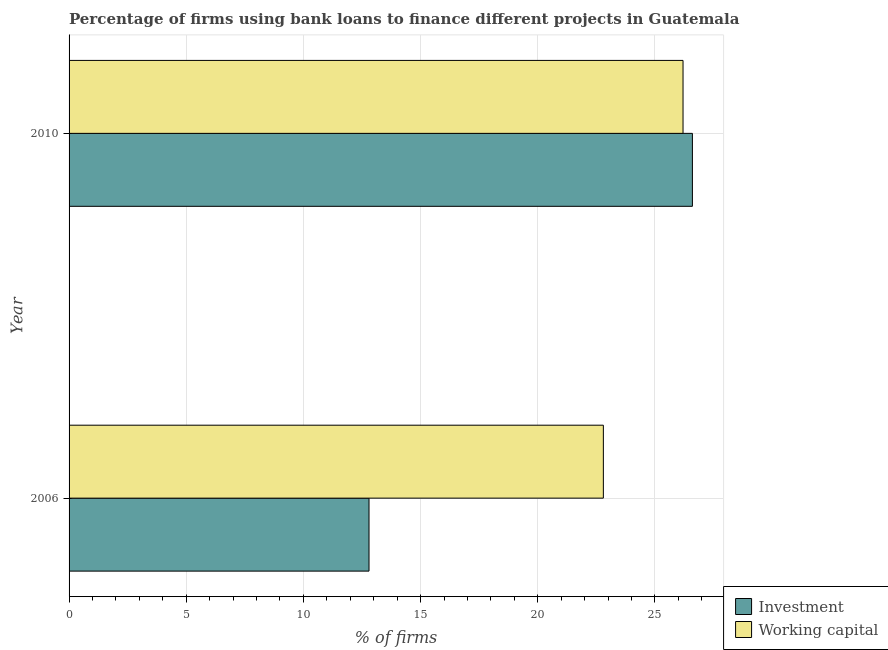Are the number of bars per tick equal to the number of legend labels?
Your answer should be compact. Yes. How many bars are there on the 2nd tick from the bottom?
Offer a very short reply. 2. What is the label of the 1st group of bars from the top?
Provide a short and direct response. 2010. In how many cases, is the number of bars for a given year not equal to the number of legend labels?
Offer a terse response. 0. What is the percentage of firms using banks to finance investment in 2006?
Give a very brief answer. 12.8. Across all years, what is the maximum percentage of firms using banks to finance working capital?
Your answer should be compact. 26.2. What is the difference between the percentage of firms using banks to finance investment in 2010 and the percentage of firms using banks to finance working capital in 2006?
Your answer should be compact. 3.8. In how many years, is the percentage of firms using banks to finance investment greater than 19 %?
Your answer should be very brief. 1. What is the ratio of the percentage of firms using banks to finance working capital in 2006 to that in 2010?
Make the answer very short. 0.87. Is the percentage of firms using banks to finance investment in 2006 less than that in 2010?
Provide a short and direct response. Yes. Is the difference between the percentage of firms using banks to finance investment in 2006 and 2010 greater than the difference between the percentage of firms using banks to finance working capital in 2006 and 2010?
Provide a succinct answer. No. In how many years, is the percentage of firms using banks to finance investment greater than the average percentage of firms using banks to finance investment taken over all years?
Ensure brevity in your answer.  1. What does the 1st bar from the top in 2010 represents?
Offer a terse response. Working capital. What does the 1st bar from the bottom in 2006 represents?
Offer a terse response. Investment. How many bars are there?
Offer a terse response. 4. Are all the bars in the graph horizontal?
Keep it short and to the point. Yes. How many years are there in the graph?
Your answer should be compact. 2. Are the values on the major ticks of X-axis written in scientific E-notation?
Offer a very short reply. No. What is the title of the graph?
Ensure brevity in your answer.  Percentage of firms using bank loans to finance different projects in Guatemala. What is the label or title of the X-axis?
Offer a very short reply. % of firms. What is the label or title of the Y-axis?
Give a very brief answer. Year. What is the % of firms of Working capital in 2006?
Make the answer very short. 22.8. What is the % of firms in Investment in 2010?
Your answer should be very brief. 26.6. What is the % of firms in Working capital in 2010?
Provide a succinct answer. 26.2. Across all years, what is the maximum % of firms of Investment?
Offer a terse response. 26.6. Across all years, what is the maximum % of firms of Working capital?
Keep it short and to the point. 26.2. Across all years, what is the minimum % of firms in Working capital?
Your response must be concise. 22.8. What is the total % of firms of Investment in the graph?
Your answer should be very brief. 39.4. What is the difference between the % of firms in Working capital in 2006 and that in 2010?
Keep it short and to the point. -3.4. What is the average % of firms in Working capital per year?
Give a very brief answer. 24.5. In the year 2006, what is the difference between the % of firms of Investment and % of firms of Working capital?
Provide a succinct answer. -10. In the year 2010, what is the difference between the % of firms of Investment and % of firms of Working capital?
Your answer should be very brief. 0.4. What is the ratio of the % of firms in Investment in 2006 to that in 2010?
Ensure brevity in your answer.  0.48. What is the ratio of the % of firms of Working capital in 2006 to that in 2010?
Provide a short and direct response. 0.87. What is the difference between the highest and the second highest % of firms in Investment?
Your answer should be compact. 13.8. What is the difference between the highest and the second highest % of firms in Working capital?
Your answer should be compact. 3.4. What is the difference between the highest and the lowest % of firms of Investment?
Your answer should be very brief. 13.8. What is the difference between the highest and the lowest % of firms of Working capital?
Ensure brevity in your answer.  3.4. 